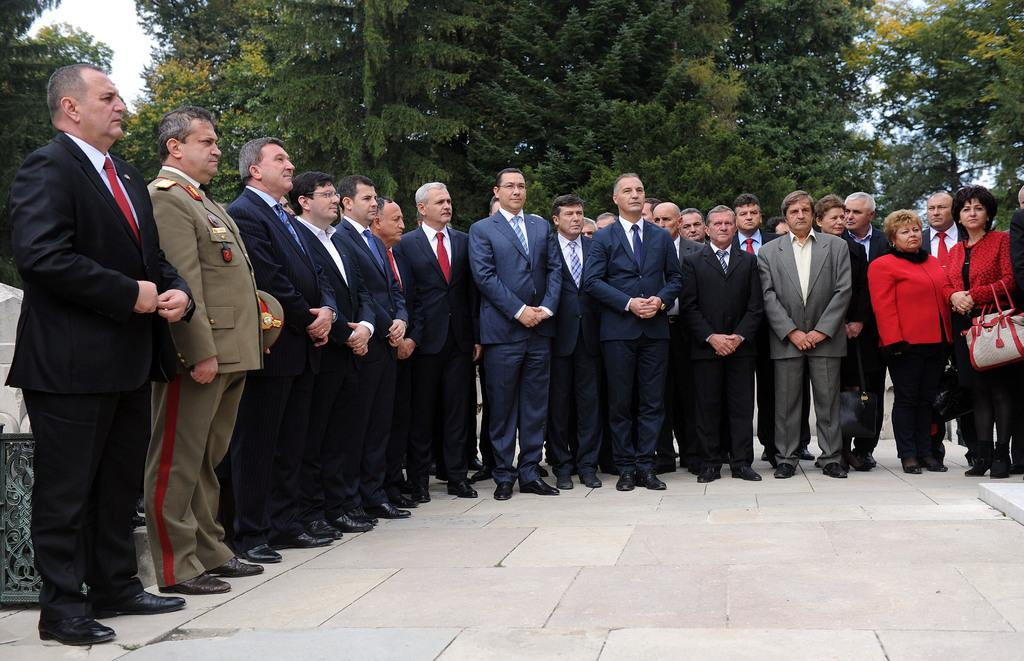How many people are in the image? There is a group of people standing in the image. What can be seen in the background of the image? There are trees and the sky visible in the background of the image. What type of drum is being played by the group of people in the image? There is no drum present in the image; it only shows a group of people standing. 